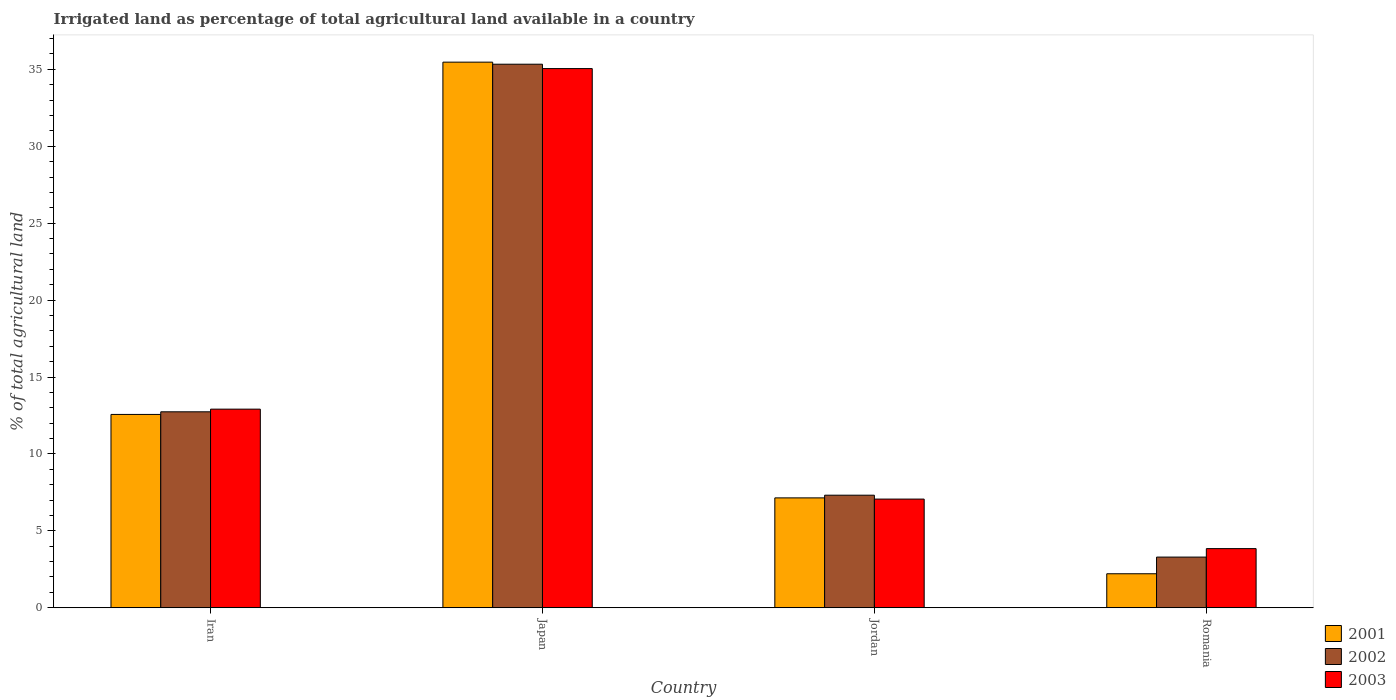Are the number of bars per tick equal to the number of legend labels?
Your answer should be very brief. Yes. Are the number of bars on each tick of the X-axis equal?
Offer a very short reply. Yes. How many bars are there on the 2nd tick from the left?
Your answer should be very brief. 3. What is the percentage of irrigated land in 2001 in Jordan?
Give a very brief answer. 7.14. Across all countries, what is the maximum percentage of irrigated land in 2003?
Offer a very short reply. 35.05. Across all countries, what is the minimum percentage of irrigated land in 2003?
Make the answer very short. 3.84. In which country was the percentage of irrigated land in 2001 maximum?
Your answer should be very brief. Japan. In which country was the percentage of irrigated land in 2003 minimum?
Offer a very short reply. Romania. What is the total percentage of irrigated land in 2002 in the graph?
Offer a very short reply. 58.68. What is the difference between the percentage of irrigated land in 2003 in Japan and that in Romania?
Offer a terse response. 31.21. What is the difference between the percentage of irrigated land in 2003 in Japan and the percentage of irrigated land in 2002 in Jordan?
Provide a succinct answer. 27.73. What is the average percentage of irrigated land in 2003 per country?
Your response must be concise. 14.72. What is the difference between the percentage of irrigated land of/in 2001 and percentage of irrigated land of/in 2002 in Jordan?
Your answer should be compact. -0.17. What is the ratio of the percentage of irrigated land in 2002 in Jordan to that in Romania?
Keep it short and to the point. 2.22. What is the difference between the highest and the second highest percentage of irrigated land in 2001?
Ensure brevity in your answer.  22.9. What is the difference between the highest and the lowest percentage of irrigated land in 2001?
Provide a succinct answer. 33.26. What does the 3rd bar from the right in Iran represents?
Give a very brief answer. 2001. Is it the case that in every country, the sum of the percentage of irrigated land in 2002 and percentage of irrigated land in 2001 is greater than the percentage of irrigated land in 2003?
Provide a succinct answer. Yes. How many countries are there in the graph?
Your answer should be very brief. 4. What is the difference between two consecutive major ticks on the Y-axis?
Ensure brevity in your answer.  5. Where does the legend appear in the graph?
Your answer should be compact. Bottom right. How are the legend labels stacked?
Offer a very short reply. Vertical. What is the title of the graph?
Your answer should be very brief. Irrigated land as percentage of total agricultural land available in a country. Does "1989" appear as one of the legend labels in the graph?
Your answer should be very brief. No. What is the label or title of the X-axis?
Ensure brevity in your answer.  Country. What is the label or title of the Y-axis?
Your answer should be very brief. % of total agricultural land. What is the % of total agricultural land in 2001 in Iran?
Keep it short and to the point. 12.57. What is the % of total agricultural land in 2002 in Iran?
Your answer should be compact. 12.74. What is the % of total agricultural land in 2003 in Iran?
Make the answer very short. 12.91. What is the % of total agricultural land in 2001 in Japan?
Your answer should be very brief. 35.47. What is the % of total agricultural land of 2002 in Japan?
Your answer should be compact. 35.33. What is the % of total agricultural land of 2003 in Japan?
Your answer should be compact. 35.05. What is the % of total agricultural land in 2001 in Jordan?
Ensure brevity in your answer.  7.14. What is the % of total agricultural land in 2002 in Jordan?
Offer a terse response. 7.32. What is the % of total agricultural land in 2003 in Jordan?
Provide a succinct answer. 7.06. What is the % of total agricultural land in 2001 in Romania?
Make the answer very short. 2.21. What is the % of total agricultural land in 2002 in Romania?
Ensure brevity in your answer.  3.29. What is the % of total agricultural land of 2003 in Romania?
Your answer should be compact. 3.84. Across all countries, what is the maximum % of total agricultural land in 2001?
Give a very brief answer. 35.47. Across all countries, what is the maximum % of total agricultural land of 2002?
Provide a succinct answer. 35.33. Across all countries, what is the maximum % of total agricultural land in 2003?
Keep it short and to the point. 35.05. Across all countries, what is the minimum % of total agricultural land in 2001?
Offer a very short reply. 2.21. Across all countries, what is the minimum % of total agricultural land in 2002?
Give a very brief answer. 3.29. Across all countries, what is the minimum % of total agricultural land of 2003?
Give a very brief answer. 3.84. What is the total % of total agricultural land in 2001 in the graph?
Your answer should be very brief. 57.39. What is the total % of total agricultural land in 2002 in the graph?
Offer a very short reply. 58.68. What is the total % of total agricultural land in 2003 in the graph?
Your response must be concise. 58.87. What is the difference between the % of total agricultural land of 2001 in Iran and that in Japan?
Your answer should be compact. -22.9. What is the difference between the % of total agricultural land in 2002 in Iran and that in Japan?
Offer a terse response. -22.6. What is the difference between the % of total agricultural land in 2003 in Iran and that in Japan?
Your answer should be very brief. -22.14. What is the difference between the % of total agricultural land in 2001 in Iran and that in Jordan?
Your answer should be compact. 5.42. What is the difference between the % of total agricultural land in 2002 in Iran and that in Jordan?
Ensure brevity in your answer.  5.42. What is the difference between the % of total agricultural land of 2003 in Iran and that in Jordan?
Offer a terse response. 5.85. What is the difference between the % of total agricultural land in 2001 in Iran and that in Romania?
Your answer should be very brief. 10.36. What is the difference between the % of total agricultural land in 2002 in Iran and that in Romania?
Your answer should be very brief. 9.44. What is the difference between the % of total agricultural land in 2003 in Iran and that in Romania?
Keep it short and to the point. 9.07. What is the difference between the % of total agricultural land in 2001 in Japan and that in Jordan?
Give a very brief answer. 28.33. What is the difference between the % of total agricultural land in 2002 in Japan and that in Jordan?
Keep it short and to the point. 28.02. What is the difference between the % of total agricultural land in 2003 in Japan and that in Jordan?
Your answer should be very brief. 27.99. What is the difference between the % of total agricultural land in 2001 in Japan and that in Romania?
Offer a very short reply. 33.26. What is the difference between the % of total agricultural land of 2002 in Japan and that in Romania?
Offer a very short reply. 32.04. What is the difference between the % of total agricultural land in 2003 in Japan and that in Romania?
Your response must be concise. 31.21. What is the difference between the % of total agricultural land in 2001 in Jordan and that in Romania?
Offer a very short reply. 4.93. What is the difference between the % of total agricultural land in 2002 in Jordan and that in Romania?
Your answer should be very brief. 4.02. What is the difference between the % of total agricultural land in 2003 in Jordan and that in Romania?
Your answer should be very brief. 3.22. What is the difference between the % of total agricultural land of 2001 in Iran and the % of total agricultural land of 2002 in Japan?
Provide a short and direct response. -22.77. What is the difference between the % of total agricultural land in 2001 in Iran and the % of total agricultural land in 2003 in Japan?
Your response must be concise. -22.48. What is the difference between the % of total agricultural land in 2002 in Iran and the % of total agricultural land in 2003 in Japan?
Offer a terse response. -22.31. What is the difference between the % of total agricultural land in 2001 in Iran and the % of total agricultural land in 2002 in Jordan?
Your answer should be compact. 5.25. What is the difference between the % of total agricultural land of 2001 in Iran and the % of total agricultural land of 2003 in Jordan?
Your answer should be very brief. 5.5. What is the difference between the % of total agricultural land in 2002 in Iran and the % of total agricultural land in 2003 in Jordan?
Make the answer very short. 5.67. What is the difference between the % of total agricultural land of 2001 in Iran and the % of total agricultural land of 2002 in Romania?
Your answer should be very brief. 9.27. What is the difference between the % of total agricultural land of 2001 in Iran and the % of total agricultural land of 2003 in Romania?
Make the answer very short. 8.72. What is the difference between the % of total agricultural land of 2002 in Iran and the % of total agricultural land of 2003 in Romania?
Offer a very short reply. 8.89. What is the difference between the % of total agricultural land in 2001 in Japan and the % of total agricultural land in 2002 in Jordan?
Keep it short and to the point. 28.15. What is the difference between the % of total agricultural land of 2001 in Japan and the % of total agricultural land of 2003 in Jordan?
Offer a very short reply. 28.4. What is the difference between the % of total agricultural land in 2002 in Japan and the % of total agricultural land in 2003 in Jordan?
Offer a terse response. 28.27. What is the difference between the % of total agricultural land of 2001 in Japan and the % of total agricultural land of 2002 in Romania?
Your response must be concise. 32.18. What is the difference between the % of total agricultural land in 2001 in Japan and the % of total agricultural land in 2003 in Romania?
Offer a terse response. 31.62. What is the difference between the % of total agricultural land in 2002 in Japan and the % of total agricultural land in 2003 in Romania?
Your answer should be compact. 31.49. What is the difference between the % of total agricultural land in 2001 in Jordan and the % of total agricultural land in 2002 in Romania?
Your answer should be compact. 3.85. What is the difference between the % of total agricultural land of 2001 in Jordan and the % of total agricultural land of 2003 in Romania?
Make the answer very short. 3.3. What is the difference between the % of total agricultural land in 2002 in Jordan and the % of total agricultural land in 2003 in Romania?
Give a very brief answer. 3.47. What is the average % of total agricultural land of 2001 per country?
Your answer should be compact. 14.35. What is the average % of total agricultural land in 2002 per country?
Provide a short and direct response. 14.67. What is the average % of total agricultural land in 2003 per country?
Make the answer very short. 14.72. What is the difference between the % of total agricultural land of 2001 and % of total agricultural land of 2002 in Iran?
Provide a succinct answer. -0.17. What is the difference between the % of total agricultural land of 2001 and % of total agricultural land of 2003 in Iran?
Provide a succinct answer. -0.34. What is the difference between the % of total agricultural land of 2002 and % of total agricultural land of 2003 in Iran?
Ensure brevity in your answer.  -0.17. What is the difference between the % of total agricultural land of 2001 and % of total agricultural land of 2002 in Japan?
Provide a short and direct response. 0.13. What is the difference between the % of total agricultural land of 2001 and % of total agricultural land of 2003 in Japan?
Provide a succinct answer. 0.42. What is the difference between the % of total agricultural land of 2002 and % of total agricultural land of 2003 in Japan?
Give a very brief answer. 0.28. What is the difference between the % of total agricultural land of 2001 and % of total agricultural land of 2002 in Jordan?
Ensure brevity in your answer.  -0.17. What is the difference between the % of total agricultural land of 2001 and % of total agricultural land of 2003 in Jordan?
Your answer should be very brief. 0.08. What is the difference between the % of total agricultural land of 2002 and % of total agricultural land of 2003 in Jordan?
Keep it short and to the point. 0.25. What is the difference between the % of total agricultural land of 2001 and % of total agricultural land of 2002 in Romania?
Give a very brief answer. -1.08. What is the difference between the % of total agricultural land in 2001 and % of total agricultural land in 2003 in Romania?
Your answer should be very brief. -1.63. What is the difference between the % of total agricultural land of 2002 and % of total agricultural land of 2003 in Romania?
Your answer should be compact. -0.55. What is the ratio of the % of total agricultural land in 2001 in Iran to that in Japan?
Your answer should be very brief. 0.35. What is the ratio of the % of total agricultural land in 2002 in Iran to that in Japan?
Your answer should be very brief. 0.36. What is the ratio of the % of total agricultural land of 2003 in Iran to that in Japan?
Your response must be concise. 0.37. What is the ratio of the % of total agricultural land in 2001 in Iran to that in Jordan?
Provide a succinct answer. 1.76. What is the ratio of the % of total agricultural land in 2002 in Iran to that in Jordan?
Offer a terse response. 1.74. What is the ratio of the % of total agricultural land in 2003 in Iran to that in Jordan?
Offer a very short reply. 1.83. What is the ratio of the % of total agricultural land in 2001 in Iran to that in Romania?
Your answer should be very brief. 5.69. What is the ratio of the % of total agricultural land of 2002 in Iran to that in Romania?
Ensure brevity in your answer.  3.87. What is the ratio of the % of total agricultural land in 2003 in Iran to that in Romania?
Provide a short and direct response. 3.36. What is the ratio of the % of total agricultural land of 2001 in Japan to that in Jordan?
Keep it short and to the point. 4.97. What is the ratio of the % of total agricultural land in 2002 in Japan to that in Jordan?
Your answer should be compact. 4.83. What is the ratio of the % of total agricultural land in 2003 in Japan to that in Jordan?
Provide a succinct answer. 4.96. What is the ratio of the % of total agricultural land of 2001 in Japan to that in Romania?
Your answer should be very brief. 16.05. What is the ratio of the % of total agricultural land in 2002 in Japan to that in Romania?
Make the answer very short. 10.73. What is the ratio of the % of total agricultural land of 2003 in Japan to that in Romania?
Provide a short and direct response. 9.12. What is the ratio of the % of total agricultural land in 2001 in Jordan to that in Romania?
Offer a very short reply. 3.23. What is the ratio of the % of total agricultural land in 2002 in Jordan to that in Romania?
Give a very brief answer. 2.22. What is the ratio of the % of total agricultural land of 2003 in Jordan to that in Romania?
Give a very brief answer. 1.84. What is the difference between the highest and the second highest % of total agricultural land of 2001?
Keep it short and to the point. 22.9. What is the difference between the highest and the second highest % of total agricultural land of 2002?
Your answer should be very brief. 22.6. What is the difference between the highest and the second highest % of total agricultural land in 2003?
Ensure brevity in your answer.  22.14. What is the difference between the highest and the lowest % of total agricultural land in 2001?
Keep it short and to the point. 33.26. What is the difference between the highest and the lowest % of total agricultural land of 2002?
Offer a terse response. 32.04. What is the difference between the highest and the lowest % of total agricultural land of 2003?
Your answer should be compact. 31.21. 